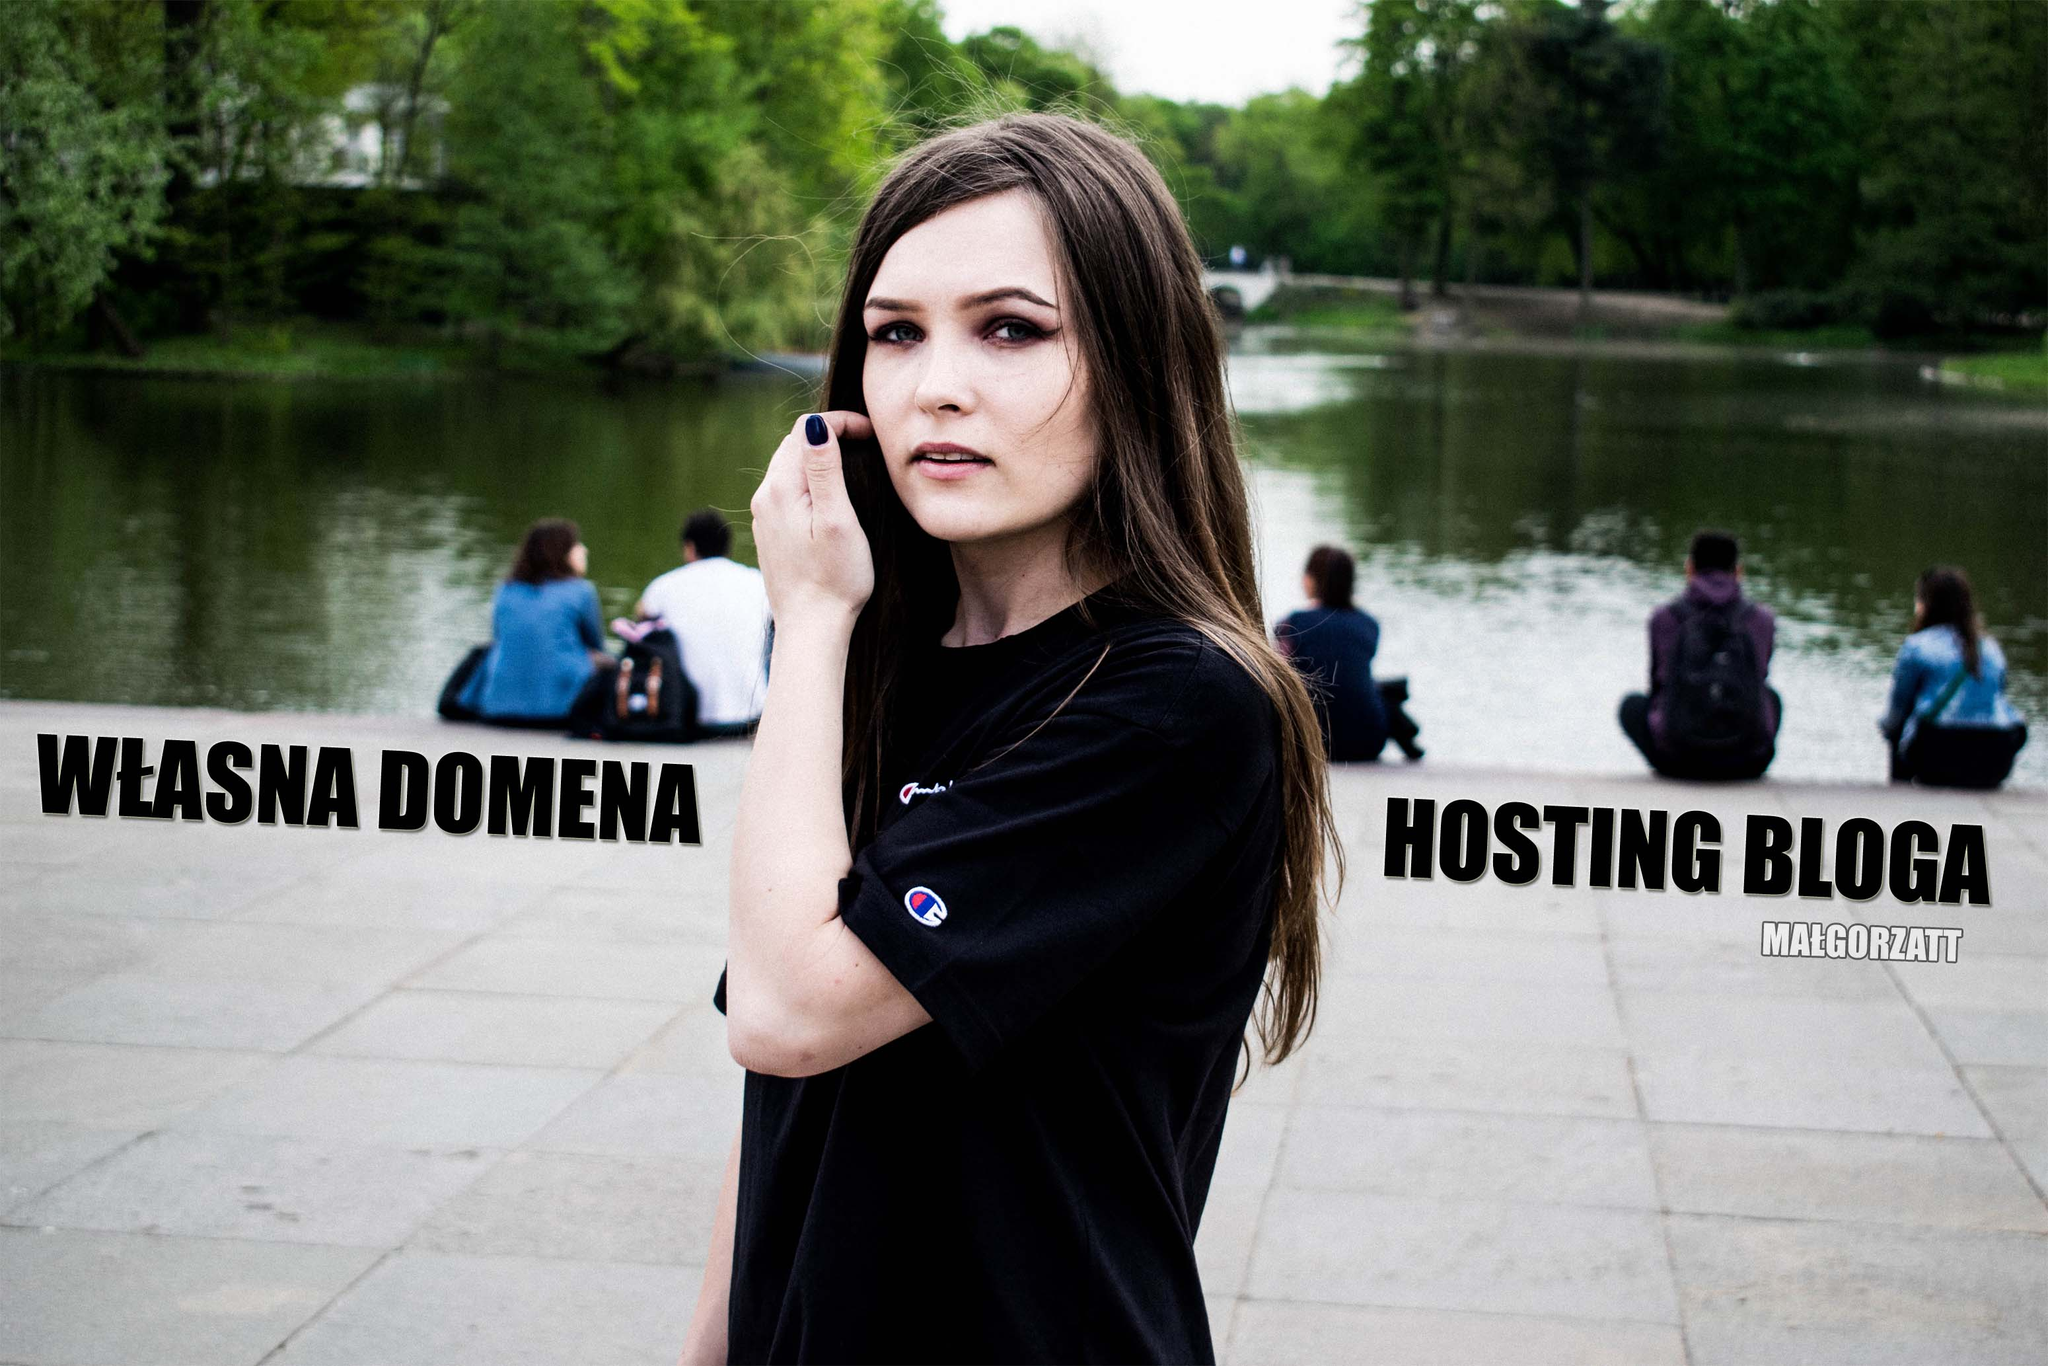Considering the elements present in the image, what might be the relationship between the text on the image and the individual photographed, based on their interaction or lack thereof? Based on the image, the text 'WŁASNA DOMENA' and 'HOSTING BLOGA' translates to 'OWN DOMAIN' and 'BLOG HOSTING,' which are relevant to the fields of website creation and management. The woman, dressed casually in a park setting, does not interact with the text, implying it was added in post-production. This suggests the text serves as an advertisement or branding element rather than having a direct relationship with her. The serene park background contrasts with the professional nature of the text, emphasizing the ad-like quality of the composite image. 